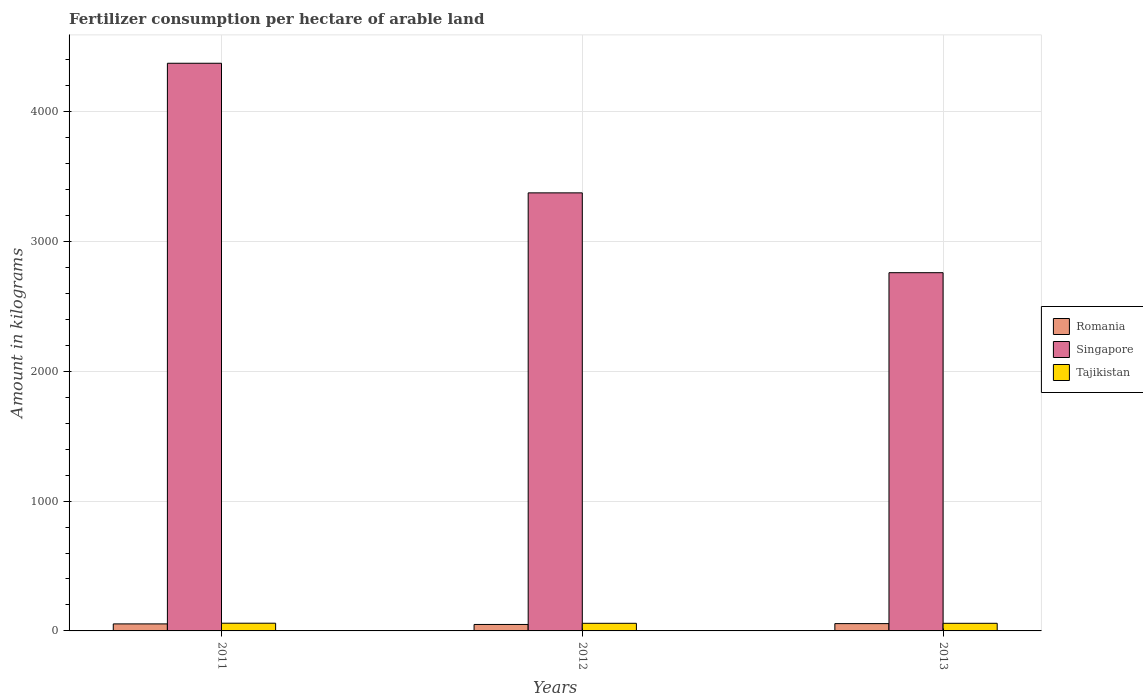How many different coloured bars are there?
Provide a short and direct response. 3. How many groups of bars are there?
Keep it short and to the point. 3. Are the number of bars per tick equal to the number of legend labels?
Provide a succinct answer. Yes. Are the number of bars on each tick of the X-axis equal?
Provide a short and direct response. Yes. How many bars are there on the 2nd tick from the left?
Offer a terse response. 3. What is the amount of fertilizer consumption in Romania in 2013?
Make the answer very short. 56.23. Across all years, what is the maximum amount of fertilizer consumption in Tajikistan?
Give a very brief answer. 59.39. Across all years, what is the minimum amount of fertilizer consumption in Romania?
Your answer should be very brief. 49.78. In which year was the amount of fertilizer consumption in Romania maximum?
Your answer should be very brief. 2013. What is the total amount of fertilizer consumption in Singapore in the graph?
Your answer should be compact. 1.05e+04. What is the difference between the amount of fertilizer consumption in Romania in 2012 and that in 2013?
Keep it short and to the point. -6.45. What is the difference between the amount of fertilizer consumption in Singapore in 2011 and the amount of fertilizer consumption in Romania in 2012?
Keep it short and to the point. 4323.24. What is the average amount of fertilizer consumption in Romania per year?
Your answer should be compact. 53.38. In the year 2012, what is the difference between the amount of fertilizer consumption in Romania and amount of fertilizer consumption in Tajikistan?
Provide a short and direct response. -8.94. What is the ratio of the amount of fertilizer consumption in Singapore in 2011 to that in 2013?
Your answer should be compact. 1.58. What is the difference between the highest and the second highest amount of fertilizer consumption in Romania?
Offer a very short reply. 2.1. What is the difference between the highest and the lowest amount of fertilizer consumption in Tajikistan?
Your answer should be very brief. 0.67. In how many years, is the amount of fertilizer consumption in Singapore greater than the average amount of fertilizer consumption in Singapore taken over all years?
Offer a very short reply. 1. What does the 2nd bar from the left in 2013 represents?
Ensure brevity in your answer.  Singapore. What does the 2nd bar from the right in 2011 represents?
Provide a short and direct response. Singapore. How many bars are there?
Provide a short and direct response. 9. Are the values on the major ticks of Y-axis written in scientific E-notation?
Offer a very short reply. No. Does the graph contain any zero values?
Offer a very short reply. No. Where does the legend appear in the graph?
Your response must be concise. Center right. How many legend labels are there?
Ensure brevity in your answer.  3. What is the title of the graph?
Your answer should be compact. Fertilizer consumption per hectare of arable land. What is the label or title of the Y-axis?
Your answer should be compact. Amount in kilograms. What is the Amount in kilograms in Romania in 2011?
Your response must be concise. 54.13. What is the Amount in kilograms of Singapore in 2011?
Your answer should be very brief. 4373.02. What is the Amount in kilograms in Tajikistan in 2011?
Make the answer very short. 59.39. What is the Amount in kilograms of Romania in 2012?
Make the answer very short. 49.78. What is the Amount in kilograms in Singapore in 2012?
Your answer should be very brief. 3374.6. What is the Amount in kilograms of Tajikistan in 2012?
Your answer should be very brief. 58.72. What is the Amount in kilograms of Romania in 2013?
Provide a succinct answer. 56.23. What is the Amount in kilograms of Singapore in 2013?
Give a very brief answer. 2759.65. What is the Amount in kilograms in Tajikistan in 2013?
Provide a short and direct response. 58.72. Across all years, what is the maximum Amount in kilograms of Romania?
Ensure brevity in your answer.  56.23. Across all years, what is the maximum Amount in kilograms of Singapore?
Offer a very short reply. 4373.02. Across all years, what is the maximum Amount in kilograms in Tajikistan?
Give a very brief answer. 59.39. Across all years, what is the minimum Amount in kilograms of Romania?
Offer a very short reply. 49.78. Across all years, what is the minimum Amount in kilograms in Singapore?
Make the answer very short. 2759.65. Across all years, what is the minimum Amount in kilograms in Tajikistan?
Your answer should be very brief. 58.72. What is the total Amount in kilograms in Romania in the graph?
Provide a short and direct response. 160.15. What is the total Amount in kilograms in Singapore in the graph?
Ensure brevity in your answer.  1.05e+04. What is the total Amount in kilograms of Tajikistan in the graph?
Keep it short and to the point. 176.83. What is the difference between the Amount in kilograms of Romania in 2011 and that in 2012?
Your answer should be compact. 4.35. What is the difference between the Amount in kilograms of Singapore in 2011 and that in 2012?
Give a very brief answer. 998.41. What is the difference between the Amount in kilograms in Tajikistan in 2011 and that in 2012?
Your answer should be very brief. 0.67. What is the difference between the Amount in kilograms in Romania in 2011 and that in 2013?
Your response must be concise. -2.1. What is the difference between the Amount in kilograms in Singapore in 2011 and that in 2013?
Offer a very short reply. 1613.37. What is the difference between the Amount in kilograms of Tajikistan in 2011 and that in 2013?
Offer a very short reply. 0.67. What is the difference between the Amount in kilograms of Romania in 2012 and that in 2013?
Ensure brevity in your answer.  -6.45. What is the difference between the Amount in kilograms of Singapore in 2012 and that in 2013?
Offer a very short reply. 614.95. What is the difference between the Amount in kilograms in Tajikistan in 2012 and that in 2013?
Offer a terse response. 0. What is the difference between the Amount in kilograms in Romania in 2011 and the Amount in kilograms in Singapore in 2012?
Make the answer very short. -3320.47. What is the difference between the Amount in kilograms in Romania in 2011 and the Amount in kilograms in Tajikistan in 2012?
Provide a succinct answer. -4.59. What is the difference between the Amount in kilograms in Singapore in 2011 and the Amount in kilograms in Tajikistan in 2012?
Offer a very short reply. 4314.29. What is the difference between the Amount in kilograms of Romania in 2011 and the Amount in kilograms of Singapore in 2013?
Make the answer very short. -2705.51. What is the difference between the Amount in kilograms in Romania in 2011 and the Amount in kilograms in Tajikistan in 2013?
Your response must be concise. -4.59. What is the difference between the Amount in kilograms in Singapore in 2011 and the Amount in kilograms in Tajikistan in 2013?
Make the answer very short. 4314.29. What is the difference between the Amount in kilograms in Romania in 2012 and the Amount in kilograms in Singapore in 2013?
Your response must be concise. -2709.87. What is the difference between the Amount in kilograms of Romania in 2012 and the Amount in kilograms of Tajikistan in 2013?
Your answer should be very brief. -8.94. What is the difference between the Amount in kilograms of Singapore in 2012 and the Amount in kilograms of Tajikistan in 2013?
Give a very brief answer. 3315.88. What is the average Amount in kilograms in Romania per year?
Provide a succinct answer. 53.38. What is the average Amount in kilograms of Singapore per year?
Make the answer very short. 3502.42. What is the average Amount in kilograms of Tajikistan per year?
Give a very brief answer. 58.94. In the year 2011, what is the difference between the Amount in kilograms of Romania and Amount in kilograms of Singapore?
Your answer should be compact. -4318.88. In the year 2011, what is the difference between the Amount in kilograms of Romania and Amount in kilograms of Tajikistan?
Offer a very short reply. -5.26. In the year 2011, what is the difference between the Amount in kilograms in Singapore and Amount in kilograms in Tajikistan?
Keep it short and to the point. 4313.62. In the year 2012, what is the difference between the Amount in kilograms in Romania and Amount in kilograms in Singapore?
Give a very brief answer. -3324.82. In the year 2012, what is the difference between the Amount in kilograms of Romania and Amount in kilograms of Tajikistan?
Your answer should be compact. -8.94. In the year 2012, what is the difference between the Amount in kilograms in Singapore and Amount in kilograms in Tajikistan?
Offer a terse response. 3315.88. In the year 2013, what is the difference between the Amount in kilograms in Romania and Amount in kilograms in Singapore?
Ensure brevity in your answer.  -2703.41. In the year 2013, what is the difference between the Amount in kilograms of Romania and Amount in kilograms of Tajikistan?
Offer a very short reply. -2.49. In the year 2013, what is the difference between the Amount in kilograms of Singapore and Amount in kilograms of Tajikistan?
Keep it short and to the point. 2700.93. What is the ratio of the Amount in kilograms in Romania in 2011 to that in 2012?
Provide a succinct answer. 1.09. What is the ratio of the Amount in kilograms in Singapore in 2011 to that in 2012?
Offer a very short reply. 1.3. What is the ratio of the Amount in kilograms of Tajikistan in 2011 to that in 2012?
Your answer should be very brief. 1.01. What is the ratio of the Amount in kilograms of Romania in 2011 to that in 2013?
Provide a succinct answer. 0.96. What is the ratio of the Amount in kilograms of Singapore in 2011 to that in 2013?
Your answer should be very brief. 1.58. What is the ratio of the Amount in kilograms of Tajikistan in 2011 to that in 2013?
Make the answer very short. 1.01. What is the ratio of the Amount in kilograms of Romania in 2012 to that in 2013?
Your answer should be compact. 0.89. What is the ratio of the Amount in kilograms of Singapore in 2012 to that in 2013?
Your answer should be compact. 1.22. What is the ratio of the Amount in kilograms of Tajikistan in 2012 to that in 2013?
Provide a short and direct response. 1. What is the difference between the highest and the second highest Amount in kilograms in Singapore?
Your response must be concise. 998.41. What is the difference between the highest and the second highest Amount in kilograms of Tajikistan?
Your response must be concise. 0.67. What is the difference between the highest and the lowest Amount in kilograms of Romania?
Make the answer very short. 6.45. What is the difference between the highest and the lowest Amount in kilograms in Singapore?
Your answer should be very brief. 1613.37. What is the difference between the highest and the lowest Amount in kilograms of Tajikistan?
Ensure brevity in your answer.  0.67. 